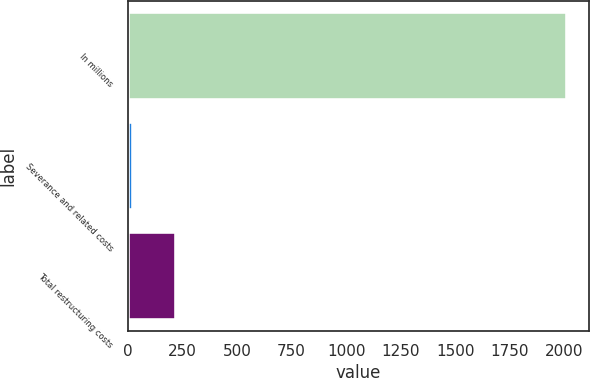Convert chart. <chart><loc_0><loc_0><loc_500><loc_500><bar_chart><fcel>In millions<fcel>Severance and related costs<fcel>Total restructuring costs<nl><fcel>2014<fcel>23.3<fcel>222.37<nl></chart> 